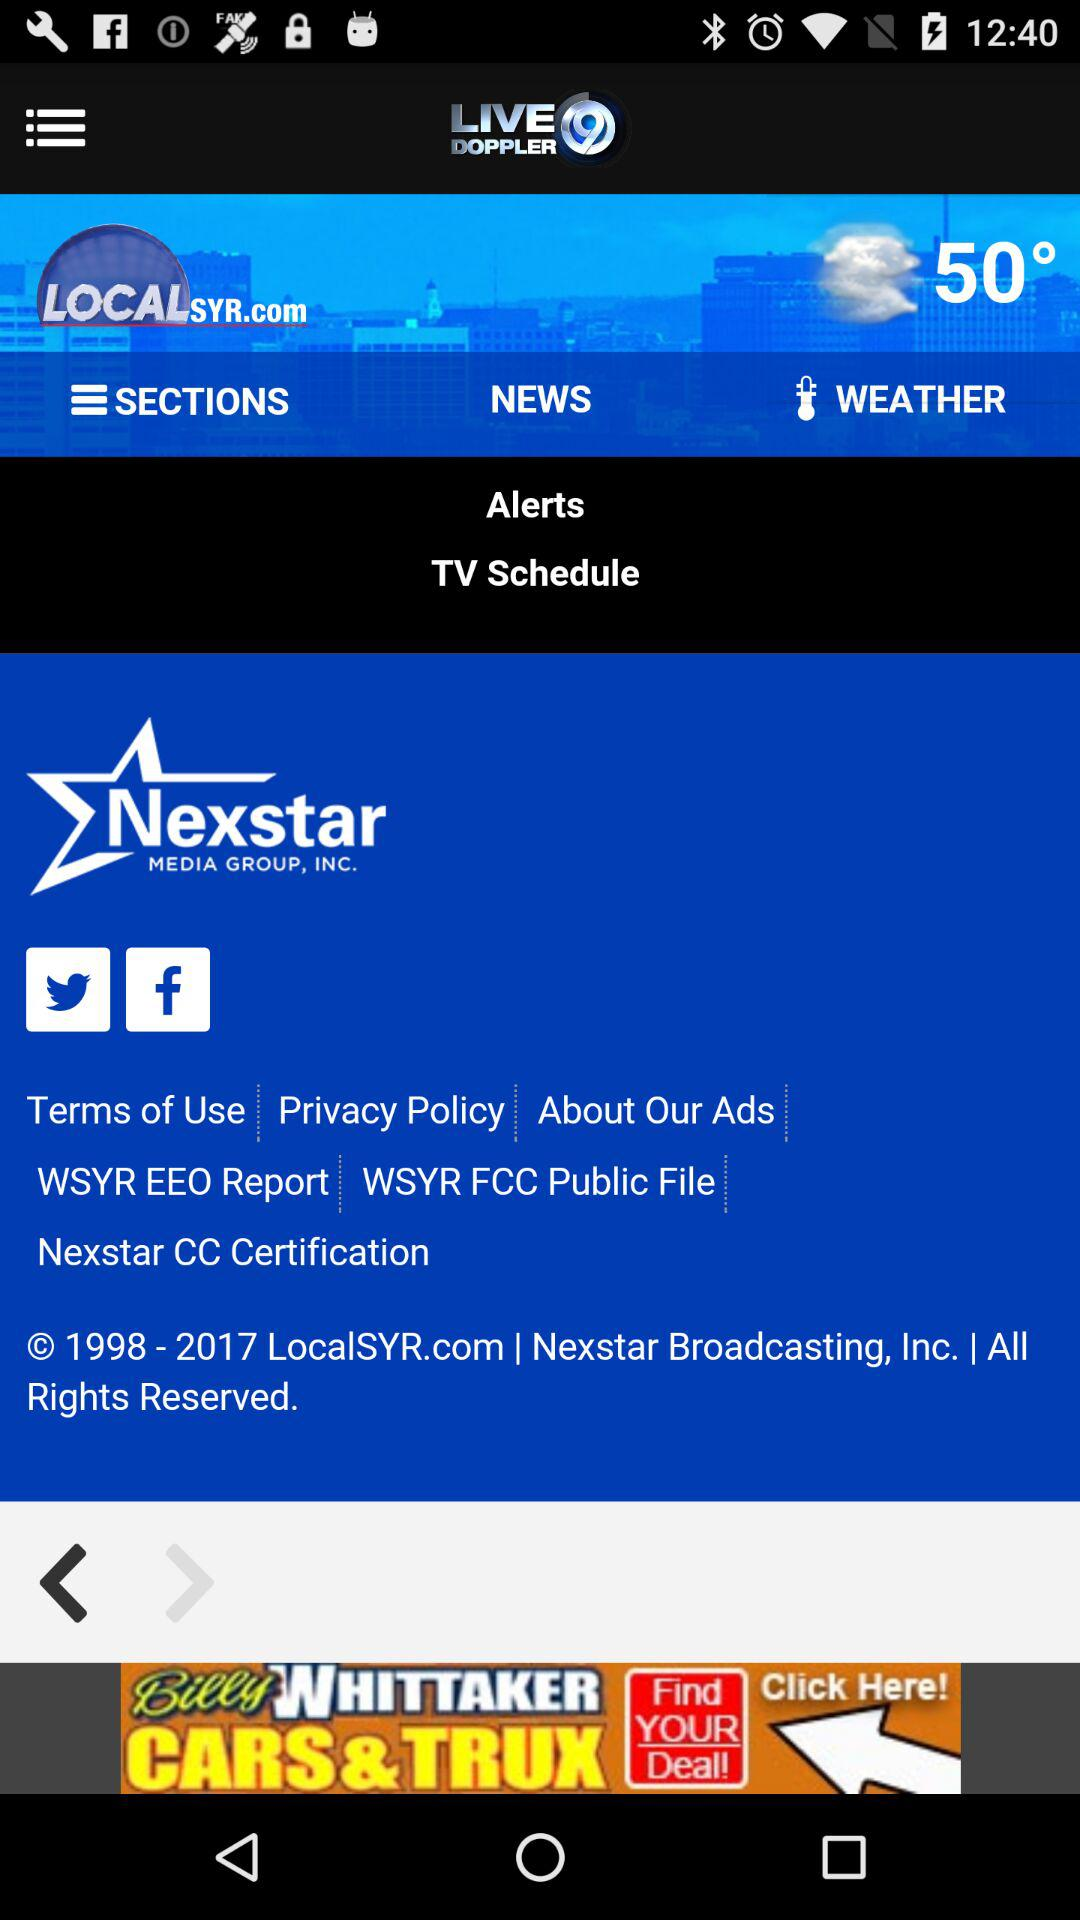What's the current temperature? The current temperature is 50°. 